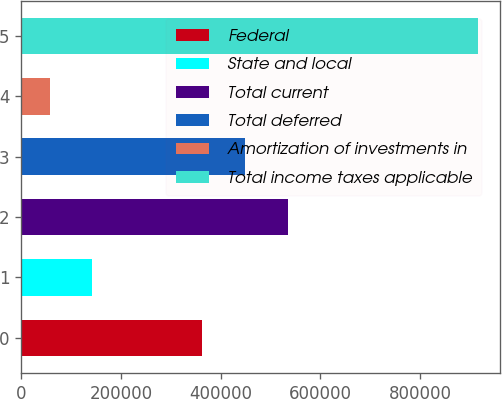Convert chart. <chart><loc_0><loc_0><loc_500><loc_500><bar_chart><fcel>Federal<fcel>State and local<fcel>Total current<fcel>Total deferred<fcel>Amortization of investments in<fcel>Total income taxes applicable<nl><fcel>363043<fcel>142864<fcel>534752<fcel>448898<fcel>57009<fcel>915556<nl></chart> 